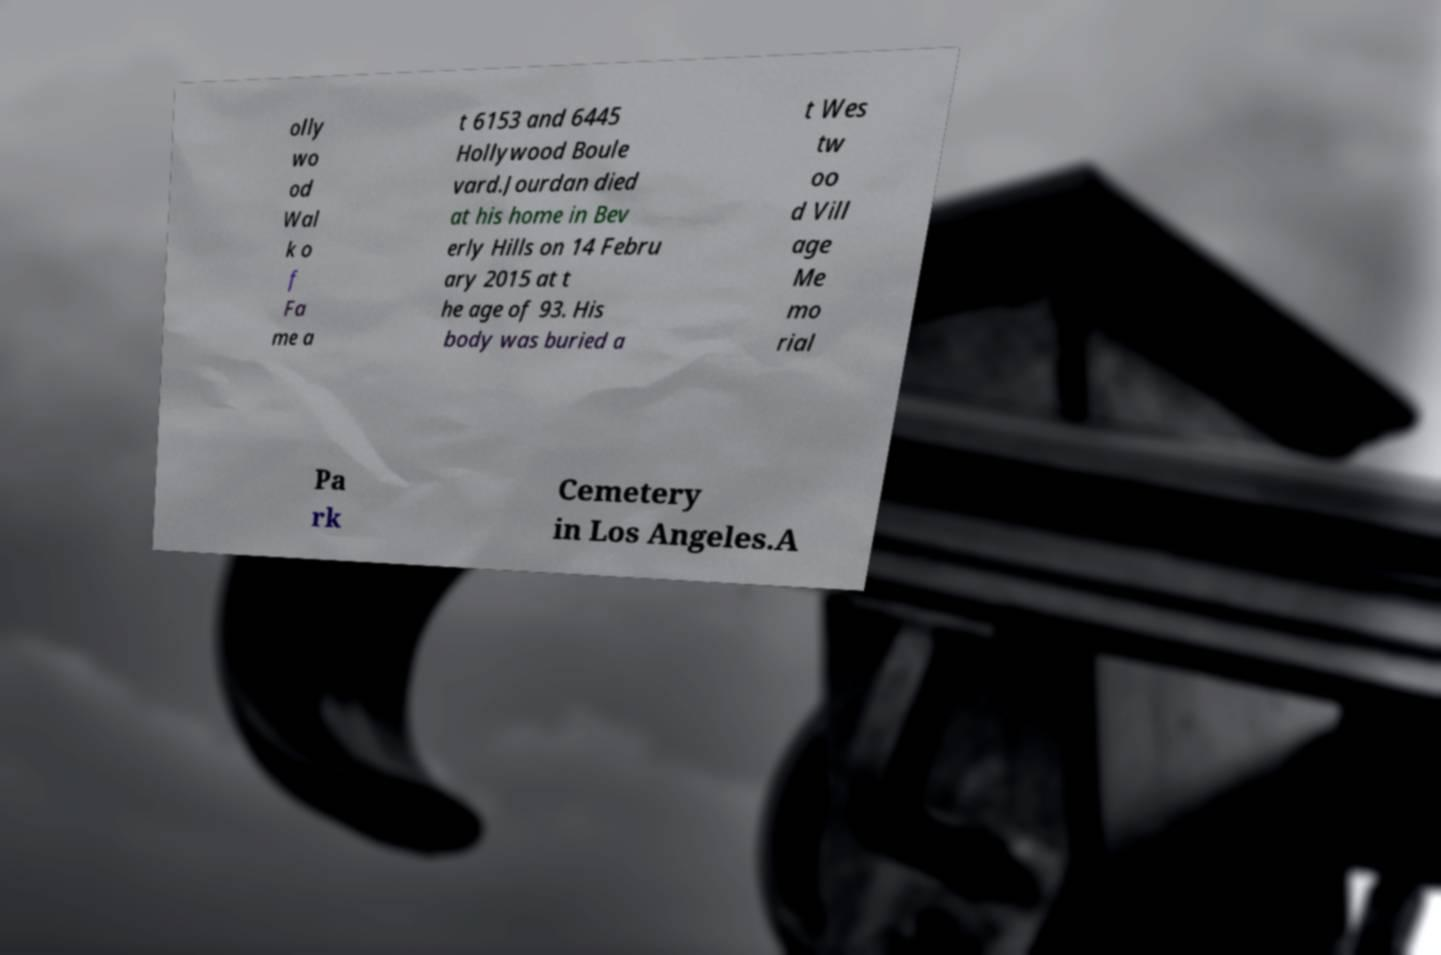For documentation purposes, I need the text within this image transcribed. Could you provide that? olly wo od Wal k o f Fa me a t 6153 and 6445 Hollywood Boule vard.Jourdan died at his home in Bev erly Hills on 14 Febru ary 2015 at t he age of 93. His body was buried a t Wes tw oo d Vill age Me mo rial Pa rk Cemetery in Los Angeles.A 